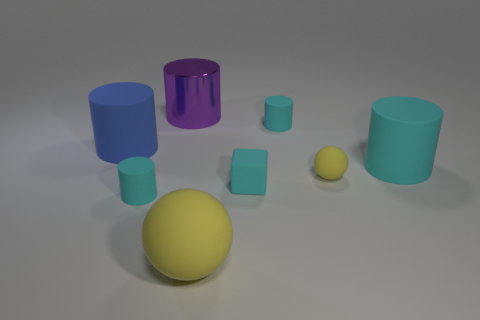Subtract all green spheres. How many cyan cylinders are left? 3 Subtract all green cylinders. Subtract all yellow blocks. How many cylinders are left? 5 Add 1 blue cylinders. How many objects exist? 9 Subtract all cubes. How many objects are left? 7 Subtract all purple cylinders. Subtract all blue matte objects. How many objects are left? 6 Add 3 tiny cyan cubes. How many tiny cyan cubes are left? 4 Add 1 large cyan matte cylinders. How many large cyan matte cylinders exist? 2 Subtract 0 green spheres. How many objects are left? 8 